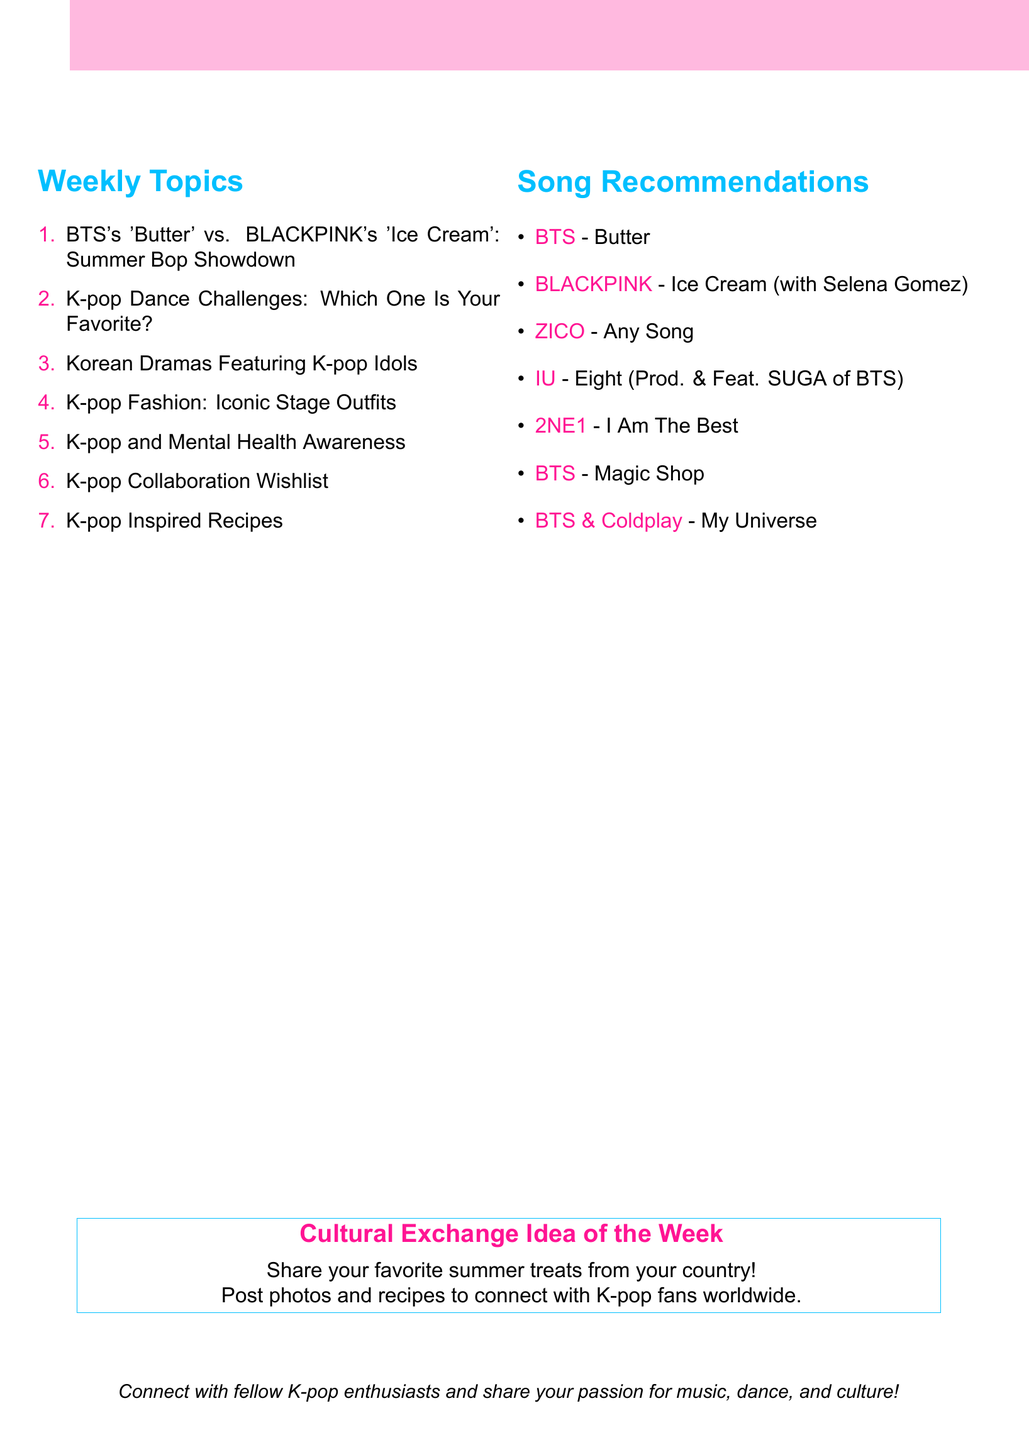What is the first weekly topic? The first weekly topic listed in the document is "BTS's 'Butter' vs. BLACKPINK's 'Ice Cream': Summer Bop Showdown."
Answer: BTS's 'Butter' vs. BLACKPINK's 'Ice Cream': Summer Bop Showdown Which song is recommended for K-pop dance challenges? The song recommended for K-pop dance challenges is "ZICO - Any Song."
Answer: ZICO - Any Song How many song recommendations are listed under K-pop and Mental Health Awareness? There are four song recommendations listed under K-pop and Mental Health Awareness in the document.
Answer: 4 What cultural exchange idea is suggested for K-pop Inspired Recipes? The cultural exchange idea suggested for K-pop Inspired Recipes is to exchange recipes inspired by K-pop songs or traditional dishes.
Answer: Exchange recipes inspired by K-pop songs or share traditional dishes from your country Which artist collaborates with Coldplay in the wishlist? The artist that collaborates with Coldplay in the wishlist is BTS.
Answer: BTS Name one of the K-pop songs associated with iconic stage outfits. One of the K-pop songs associated with iconic stage outfits is "2NE1 - I Am The Best."
Answer: 2NE1 - I Am The Best What is the theme for the second week of discussion? The theme for the second week of discussion is K-pop Dance Challenges.
Answer: K-pop Dance Challenges How many total weekly topics are listed in the document? There are a total of seven weekly topics listed in the document.
Answer: 7 What is the main color theme used in the document? The main colors used in the document are kpoppink and kpopblue.
Answer: kpoppink and kpopblue 